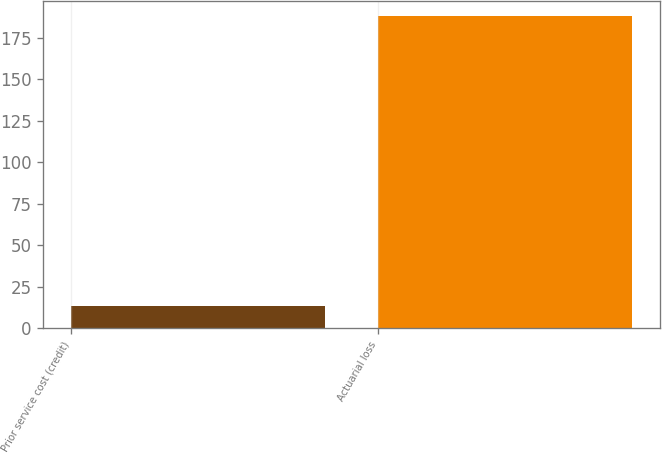Convert chart. <chart><loc_0><loc_0><loc_500><loc_500><bar_chart><fcel>Prior service cost (credit)<fcel>Actuarial loss<nl><fcel>13<fcel>188<nl></chart> 